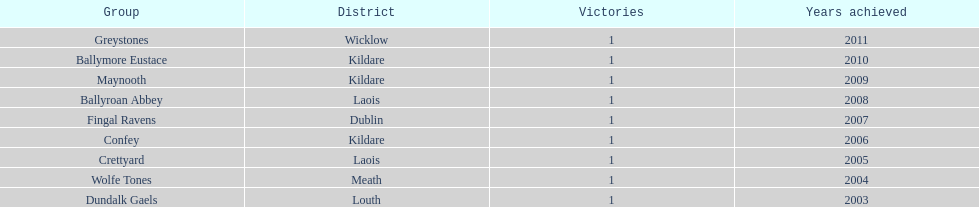Which team emerged victorious after ballymore eustace? Greystones. Could you parse the entire table? {'header': ['Group', 'District', 'Victories', 'Years achieved'], 'rows': [['Greystones', 'Wicklow', '1', '2011'], ['Ballymore Eustace', 'Kildare', '1', '2010'], ['Maynooth', 'Kildare', '1', '2009'], ['Ballyroan Abbey', 'Laois', '1', '2008'], ['Fingal Ravens', 'Dublin', '1', '2007'], ['Confey', 'Kildare', '1', '2006'], ['Crettyard', 'Laois', '1', '2005'], ['Wolfe Tones', 'Meath', '1', '2004'], ['Dundalk Gaels', 'Louth', '1', '2003']]} 